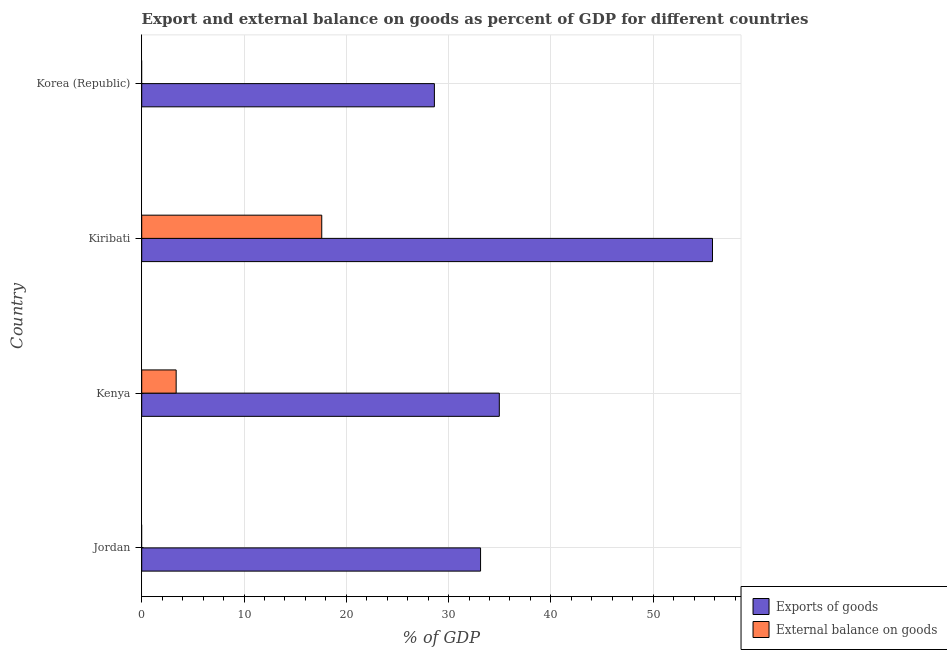How many different coloured bars are there?
Provide a succinct answer. 2. Are the number of bars per tick equal to the number of legend labels?
Give a very brief answer. No. Are the number of bars on each tick of the Y-axis equal?
Make the answer very short. No. How many bars are there on the 4th tick from the bottom?
Offer a terse response. 1. What is the label of the 3rd group of bars from the top?
Your response must be concise. Kenya. What is the external balance on goods as percentage of gdp in Kiribati?
Provide a short and direct response. 17.6. Across all countries, what is the maximum export of goods as percentage of gdp?
Give a very brief answer. 55.8. Across all countries, what is the minimum export of goods as percentage of gdp?
Your answer should be very brief. 28.61. In which country was the export of goods as percentage of gdp maximum?
Provide a short and direct response. Kiribati. What is the total export of goods as percentage of gdp in the graph?
Your answer should be compact. 152.5. What is the difference between the export of goods as percentage of gdp in Kenya and that in Korea (Republic)?
Give a very brief answer. 6.35. What is the difference between the external balance on goods as percentage of gdp in Kenya and the export of goods as percentage of gdp in Kiribati?
Provide a succinct answer. -52.43. What is the average external balance on goods as percentage of gdp per country?
Your response must be concise. 5.24. What is the difference between the external balance on goods as percentage of gdp and export of goods as percentage of gdp in Kiribati?
Your response must be concise. -38.2. In how many countries, is the external balance on goods as percentage of gdp greater than 36 %?
Provide a succinct answer. 0. What is the ratio of the export of goods as percentage of gdp in Jordan to that in Kenya?
Your answer should be very brief. 0.95. Is the export of goods as percentage of gdp in Jordan less than that in Kiribati?
Ensure brevity in your answer.  Yes. What is the difference between the highest and the second highest export of goods as percentage of gdp?
Ensure brevity in your answer.  20.84. What is the difference between the highest and the lowest export of goods as percentage of gdp?
Provide a short and direct response. 27.19. In how many countries, is the external balance on goods as percentage of gdp greater than the average external balance on goods as percentage of gdp taken over all countries?
Keep it short and to the point. 1. Is the sum of the export of goods as percentage of gdp in Kiribati and Korea (Republic) greater than the maximum external balance on goods as percentage of gdp across all countries?
Keep it short and to the point. Yes. How many bars are there?
Offer a terse response. 6. What is the difference between two consecutive major ticks on the X-axis?
Make the answer very short. 10. Are the values on the major ticks of X-axis written in scientific E-notation?
Your answer should be compact. No. Does the graph contain grids?
Your answer should be compact. Yes. Where does the legend appear in the graph?
Ensure brevity in your answer.  Bottom right. How many legend labels are there?
Keep it short and to the point. 2. What is the title of the graph?
Your response must be concise. Export and external balance on goods as percent of GDP for different countries. Does "Nonresident" appear as one of the legend labels in the graph?
Provide a short and direct response. No. What is the label or title of the X-axis?
Your answer should be compact. % of GDP. What is the % of GDP in Exports of goods in Jordan?
Provide a short and direct response. 33.13. What is the % of GDP of External balance on goods in Jordan?
Offer a very short reply. 0. What is the % of GDP in Exports of goods in Kenya?
Offer a terse response. 34.96. What is the % of GDP of External balance on goods in Kenya?
Give a very brief answer. 3.37. What is the % of GDP of Exports of goods in Kiribati?
Offer a terse response. 55.8. What is the % of GDP in External balance on goods in Kiribati?
Your response must be concise. 17.6. What is the % of GDP of Exports of goods in Korea (Republic)?
Offer a terse response. 28.61. Across all countries, what is the maximum % of GDP of Exports of goods?
Provide a succinct answer. 55.8. Across all countries, what is the maximum % of GDP in External balance on goods?
Your response must be concise. 17.6. Across all countries, what is the minimum % of GDP in Exports of goods?
Give a very brief answer. 28.61. Across all countries, what is the minimum % of GDP of External balance on goods?
Offer a very short reply. 0. What is the total % of GDP in Exports of goods in the graph?
Your response must be concise. 152.5. What is the total % of GDP of External balance on goods in the graph?
Offer a very short reply. 20.97. What is the difference between the % of GDP in Exports of goods in Jordan and that in Kenya?
Your answer should be very brief. -1.83. What is the difference between the % of GDP of Exports of goods in Jordan and that in Kiribati?
Provide a short and direct response. -22.67. What is the difference between the % of GDP in Exports of goods in Jordan and that in Korea (Republic)?
Offer a very short reply. 4.51. What is the difference between the % of GDP of Exports of goods in Kenya and that in Kiribati?
Your answer should be compact. -20.84. What is the difference between the % of GDP of External balance on goods in Kenya and that in Kiribati?
Keep it short and to the point. -14.23. What is the difference between the % of GDP in Exports of goods in Kenya and that in Korea (Republic)?
Make the answer very short. 6.35. What is the difference between the % of GDP in Exports of goods in Kiribati and that in Korea (Republic)?
Offer a very short reply. 27.19. What is the difference between the % of GDP of Exports of goods in Jordan and the % of GDP of External balance on goods in Kenya?
Provide a short and direct response. 29.76. What is the difference between the % of GDP of Exports of goods in Jordan and the % of GDP of External balance on goods in Kiribati?
Make the answer very short. 15.53. What is the difference between the % of GDP of Exports of goods in Kenya and the % of GDP of External balance on goods in Kiribati?
Give a very brief answer. 17.36. What is the average % of GDP in Exports of goods per country?
Ensure brevity in your answer.  38.12. What is the average % of GDP in External balance on goods per country?
Give a very brief answer. 5.24. What is the difference between the % of GDP of Exports of goods and % of GDP of External balance on goods in Kenya?
Give a very brief answer. 31.59. What is the difference between the % of GDP of Exports of goods and % of GDP of External balance on goods in Kiribati?
Provide a succinct answer. 38.2. What is the ratio of the % of GDP in Exports of goods in Jordan to that in Kenya?
Give a very brief answer. 0.95. What is the ratio of the % of GDP of Exports of goods in Jordan to that in Kiribati?
Your answer should be compact. 0.59. What is the ratio of the % of GDP of Exports of goods in Jordan to that in Korea (Republic)?
Keep it short and to the point. 1.16. What is the ratio of the % of GDP of Exports of goods in Kenya to that in Kiribati?
Your response must be concise. 0.63. What is the ratio of the % of GDP of External balance on goods in Kenya to that in Kiribati?
Provide a short and direct response. 0.19. What is the ratio of the % of GDP of Exports of goods in Kenya to that in Korea (Republic)?
Offer a very short reply. 1.22. What is the ratio of the % of GDP of Exports of goods in Kiribati to that in Korea (Republic)?
Your response must be concise. 1.95. What is the difference between the highest and the second highest % of GDP of Exports of goods?
Keep it short and to the point. 20.84. What is the difference between the highest and the lowest % of GDP of Exports of goods?
Your response must be concise. 27.19. What is the difference between the highest and the lowest % of GDP in External balance on goods?
Make the answer very short. 17.6. 